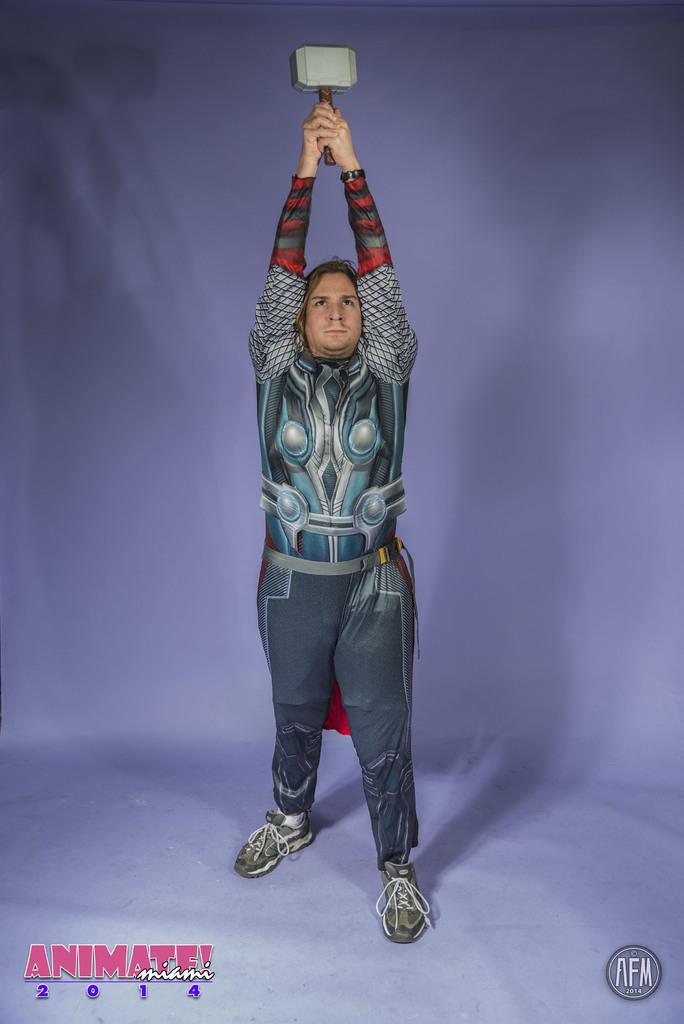Please provide a concise description of this image. In the image we can see there is a person standing and he is wearing costume. He is holding thor hammer in his hand. 